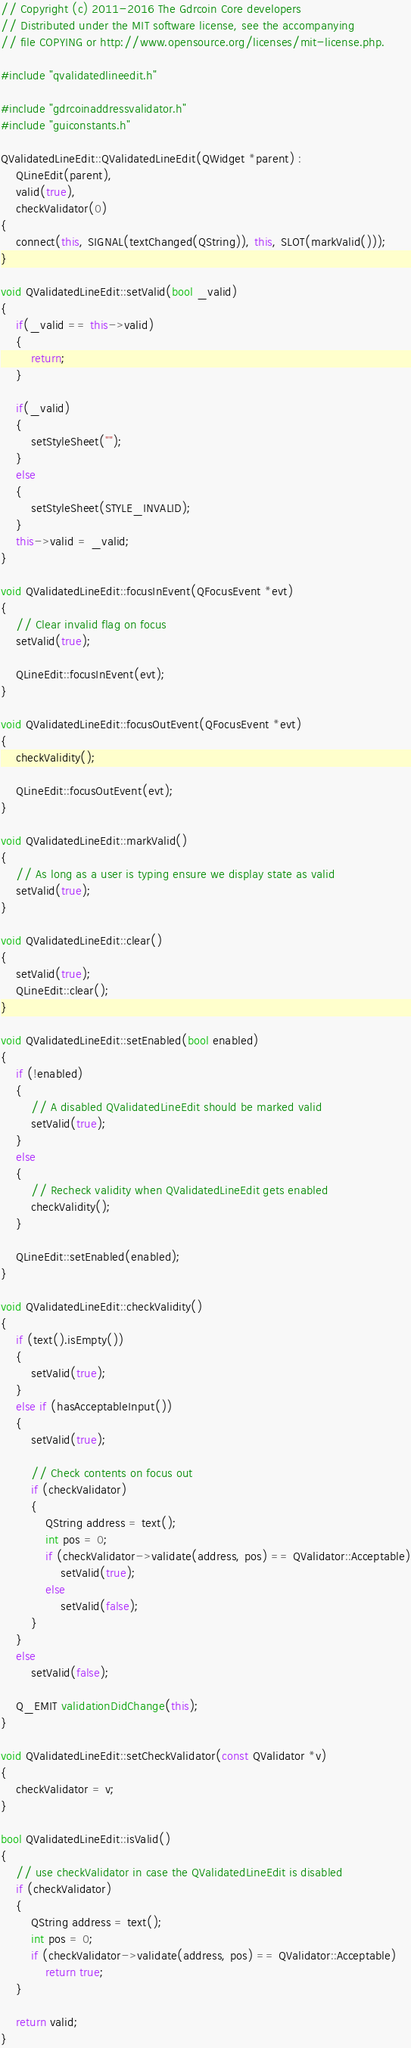<code> <loc_0><loc_0><loc_500><loc_500><_C++_>// Copyright (c) 2011-2016 The Gdrcoin Core developers
// Distributed under the MIT software license, see the accompanying
// file COPYING or http://www.opensource.org/licenses/mit-license.php.

#include "qvalidatedlineedit.h"

#include "gdrcoinaddressvalidator.h"
#include "guiconstants.h"

QValidatedLineEdit::QValidatedLineEdit(QWidget *parent) :
    QLineEdit(parent),
    valid(true),
    checkValidator(0)
{
    connect(this, SIGNAL(textChanged(QString)), this, SLOT(markValid()));
}

void QValidatedLineEdit::setValid(bool _valid)
{
    if(_valid == this->valid)
    {
        return;
    }

    if(_valid)
    {
        setStyleSheet("");
    }
    else
    {
        setStyleSheet(STYLE_INVALID);
    }
    this->valid = _valid;
}

void QValidatedLineEdit::focusInEvent(QFocusEvent *evt)
{
    // Clear invalid flag on focus
    setValid(true);

    QLineEdit::focusInEvent(evt);
}

void QValidatedLineEdit::focusOutEvent(QFocusEvent *evt)
{
    checkValidity();

    QLineEdit::focusOutEvent(evt);
}

void QValidatedLineEdit::markValid()
{
    // As long as a user is typing ensure we display state as valid
    setValid(true);
}

void QValidatedLineEdit::clear()
{
    setValid(true);
    QLineEdit::clear();
}

void QValidatedLineEdit::setEnabled(bool enabled)
{
    if (!enabled)
    {
        // A disabled QValidatedLineEdit should be marked valid
        setValid(true);
    }
    else
    {
        // Recheck validity when QValidatedLineEdit gets enabled
        checkValidity();
    }

    QLineEdit::setEnabled(enabled);
}

void QValidatedLineEdit::checkValidity()
{
    if (text().isEmpty())
    {
        setValid(true);
    }
    else if (hasAcceptableInput())
    {
        setValid(true);

        // Check contents on focus out
        if (checkValidator)
        {
            QString address = text();
            int pos = 0;
            if (checkValidator->validate(address, pos) == QValidator::Acceptable)
                setValid(true);
            else
                setValid(false);
        }
    }
    else
        setValid(false);

    Q_EMIT validationDidChange(this);
}

void QValidatedLineEdit::setCheckValidator(const QValidator *v)
{
    checkValidator = v;
}

bool QValidatedLineEdit::isValid()
{
    // use checkValidator in case the QValidatedLineEdit is disabled
    if (checkValidator)
    {
        QString address = text();
        int pos = 0;
        if (checkValidator->validate(address, pos) == QValidator::Acceptable)
            return true;
    }

    return valid;
}
</code> 